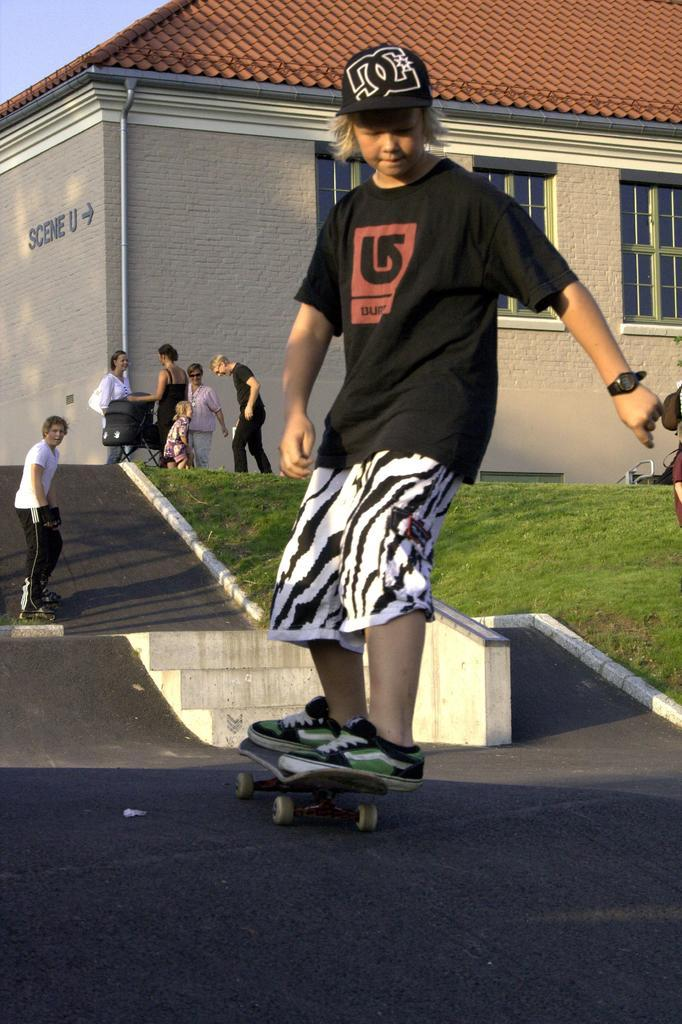Who can be seen in the image? There are people in the image. Can you describe one of the individuals in the image? There is a man in the image. What is the man doing in the image? The man is skating using a skateboard. What can be seen in the background of the image? There is grass and a house visible in the background of the image. What type of riddle is the man trying to solve while skating in the image? There is no indication in the image that the man is trying to solve a riddle while skating. 